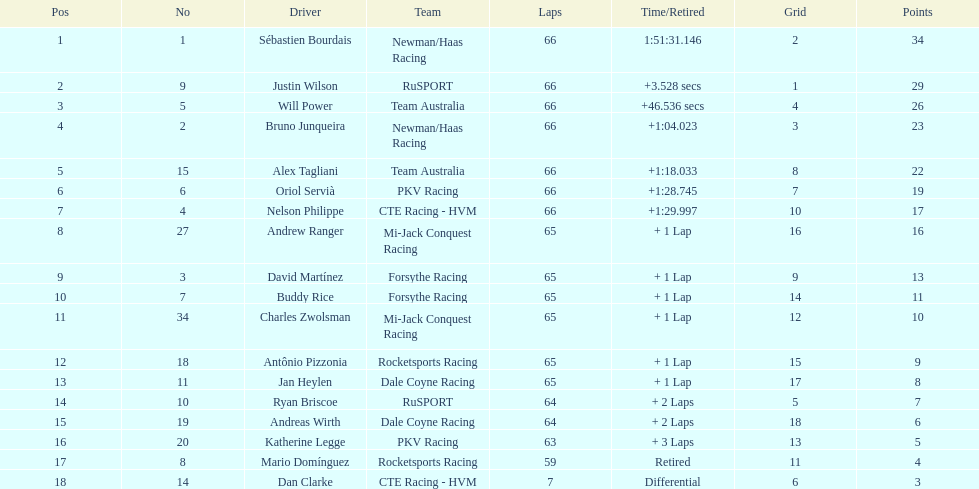Which racer finished just behind the one who had a finishing time of 1:2 Nelson Philippe. 